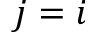Convert formula to latex. <formula><loc_0><loc_0><loc_500><loc_500>j = i</formula> 